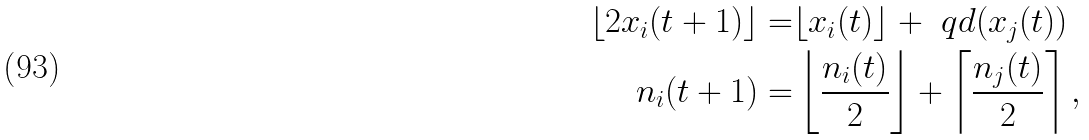Convert formula to latex. <formula><loc_0><loc_0><loc_500><loc_500>\lfloor 2 x _ { i } ( t + 1 ) \rfloor = & \lfloor x _ { i } ( t ) \rfloor + \ q d ( x _ { j } ( t ) ) \\ n _ { i } ( t + 1 ) = & \left \lfloor \frac { n _ { i } ( t ) } { 2 } \right \rfloor + \left \lceil \frac { n _ { j } ( t ) } { 2 } \right \rceil ,</formula> 